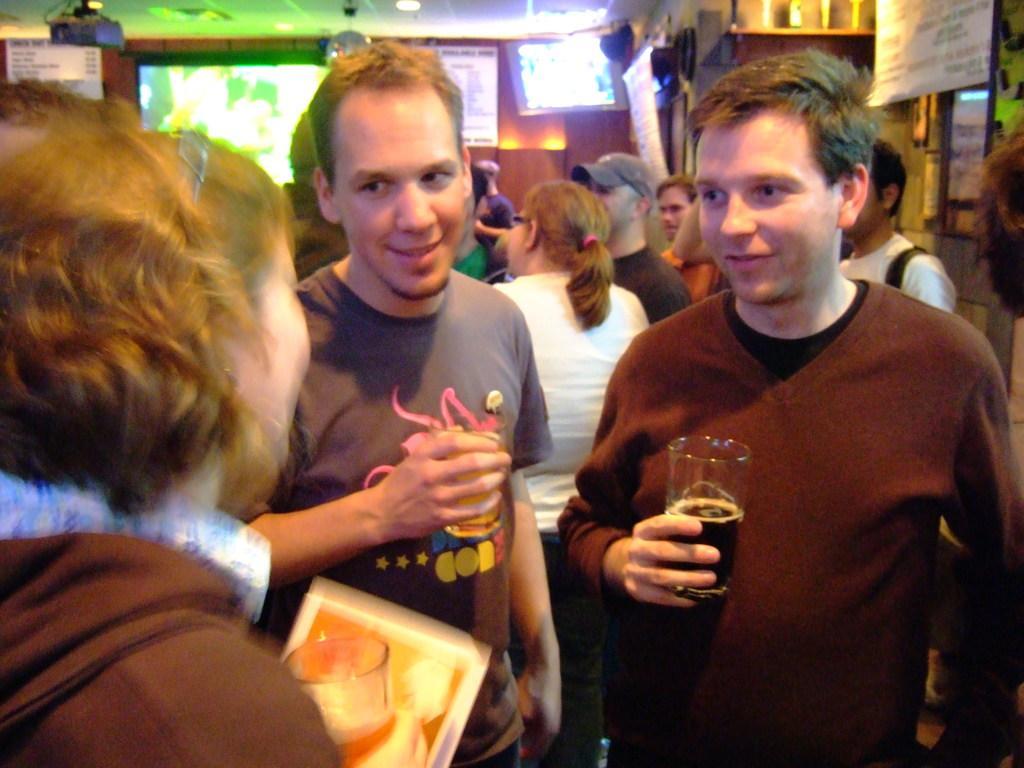Can you describe this image briefly? In this image I can see number of people are standing. Here I can see two men are holding glasses. In the background I can see few lights and a screen. 